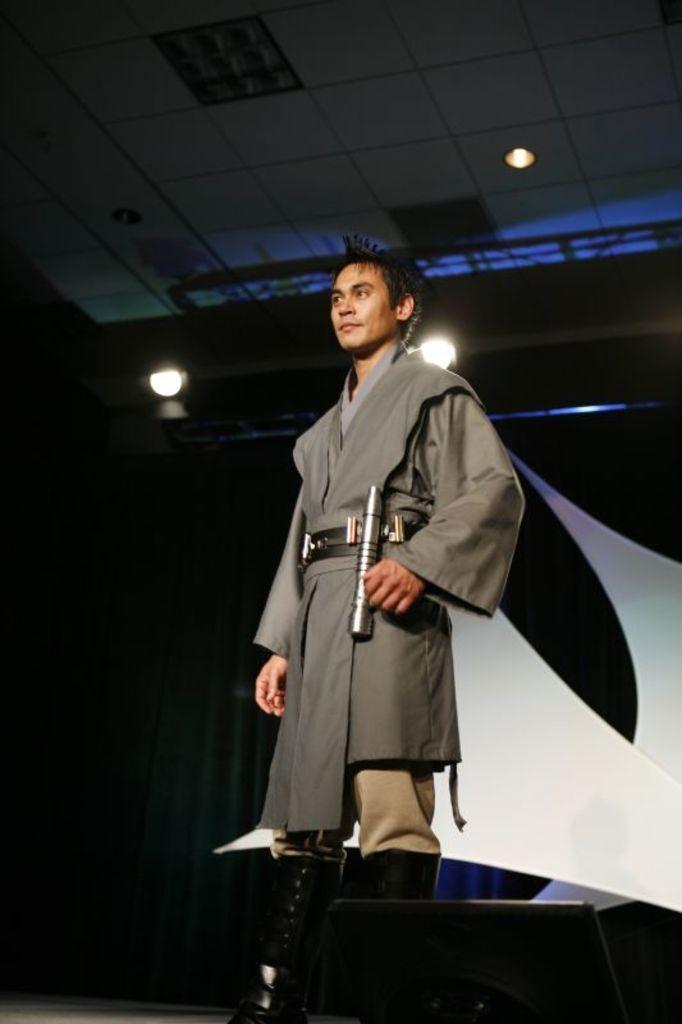Describe this image in one or two sentences. In this image, we can see a person standing, there is a dark background, we can see some lights and the roof. 